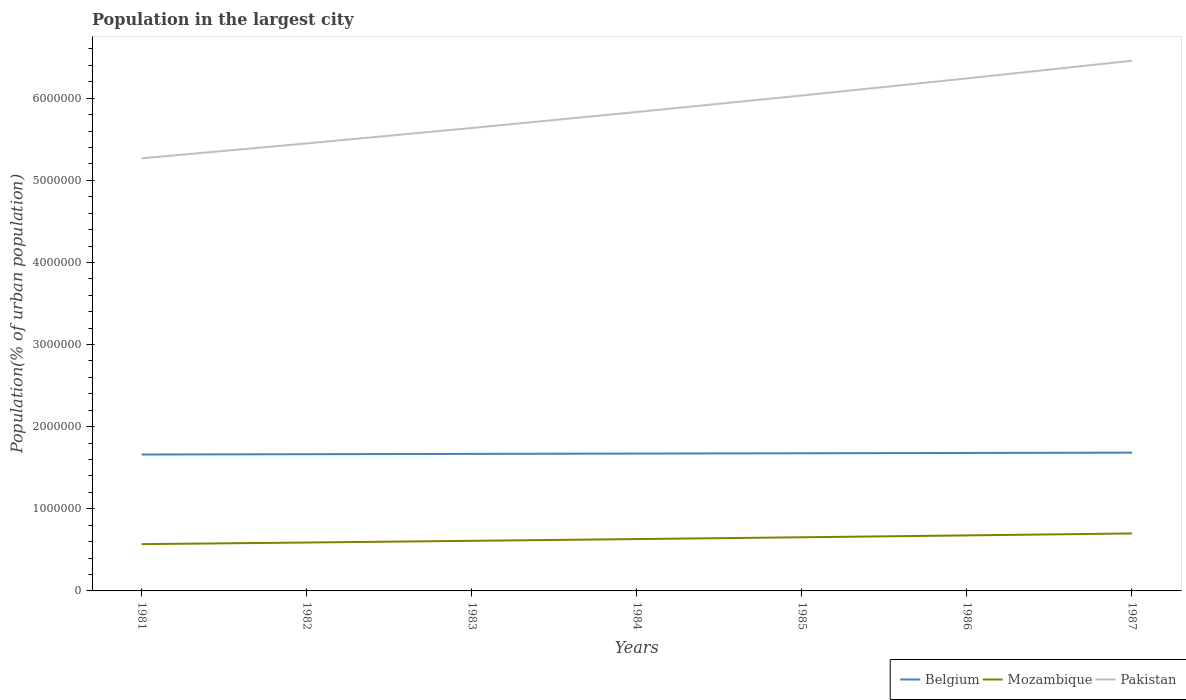Does the line corresponding to Mozambique intersect with the line corresponding to Belgium?
Ensure brevity in your answer.  No. Across all years, what is the maximum population in the largest city in Mozambique?
Your answer should be compact. 5.70e+05. In which year was the population in the largest city in Pakistan maximum?
Offer a terse response. 1981. What is the total population in the largest city in Belgium in the graph?
Offer a very short reply. -1.15e+04. What is the difference between the highest and the second highest population in the largest city in Mozambique?
Your answer should be very brief. 1.30e+05. Is the population in the largest city in Belgium strictly greater than the population in the largest city in Pakistan over the years?
Your answer should be very brief. Yes. How many years are there in the graph?
Make the answer very short. 7. Does the graph contain any zero values?
Your answer should be compact. No. Does the graph contain grids?
Your answer should be compact. No. How many legend labels are there?
Offer a very short reply. 3. What is the title of the graph?
Offer a very short reply. Population in the largest city. What is the label or title of the X-axis?
Provide a short and direct response. Years. What is the label or title of the Y-axis?
Make the answer very short. Population(% of urban population). What is the Population(% of urban population) of Belgium in 1981?
Make the answer very short. 1.66e+06. What is the Population(% of urban population) of Mozambique in 1981?
Your answer should be very brief. 5.70e+05. What is the Population(% of urban population) in Pakistan in 1981?
Ensure brevity in your answer.  5.27e+06. What is the Population(% of urban population) in Belgium in 1982?
Your response must be concise. 1.66e+06. What is the Population(% of urban population) of Mozambique in 1982?
Ensure brevity in your answer.  5.89e+05. What is the Population(% of urban population) in Pakistan in 1982?
Provide a succinct answer. 5.45e+06. What is the Population(% of urban population) of Belgium in 1983?
Your answer should be compact. 1.67e+06. What is the Population(% of urban population) in Mozambique in 1983?
Make the answer very short. 6.10e+05. What is the Population(% of urban population) in Pakistan in 1983?
Your answer should be compact. 5.64e+06. What is the Population(% of urban population) in Belgium in 1984?
Offer a terse response. 1.67e+06. What is the Population(% of urban population) of Mozambique in 1984?
Your answer should be very brief. 6.31e+05. What is the Population(% of urban population) of Pakistan in 1984?
Your answer should be compact. 5.83e+06. What is the Population(% of urban population) in Belgium in 1985?
Offer a terse response. 1.68e+06. What is the Population(% of urban population) of Mozambique in 1985?
Keep it short and to the point. 6.53e+05. What is the Population(% of urban population) in Pakistan in 1985?
Offer a very short reply. 6.03e+06. What is the Population(% of urban population) of Belgium in 1986?
Give a very brief answer. 1.68e+06. What is the Population(% of urban population) in Mozambique in 1986?
Your answer should be very brief. 6.76e+05. What is the Population(% of urban population) of Pakistan in 1986?
Provide a short and direct response. 6.24e+06. What is the Population(% of urban population) of Belgium in 1987?
Provide a short and direct response. 1.68e+06. What is the Population(% of urban population) of Mozambique in 1987?
Your answer should be very brief. 7.00e+05. What is the Population(% of urban population) in Pakistan in 1987?
Provide a short and direct response. 6.46e+06. Across all years, what is the maximum Population(% of urban population) of Belgium?
Keep it short and to the point. 1.68e+06. Across all years, what is the maximum Population(% of urban population) of Mozambique?
Keep it short and to the point. 7.00e+05. Across all years, what is the maximum Population(% of urban population) in Pakistan?
Offer a terse response. 6.46e+06. Across all years, what is the minimum Population(% of urban population) in Belgium?
Your answer should be compact. 1.66e+06. Across all years, what is the minimum Population(% of urban population) of Mozambique?
Make the answer very short. 5.70e+05. Across all years, what is the minimum Population(% of urban population) of Pakistan?
Make the answer very short. 5.27e+06. What is the total Population(% of urban population) in Belgium in the graph?
Your answer should be very brief. 1.17e+07. What is the total Population(% of urban population) in Mozambique in the graph?
Offer a very short reply. 4.43e+06. What is the total Population(% of urban population) of Pakistan in the graph?
Your response must be concise. 4.09e+07. What is the difference between the Population(% of urban population) of Belgium in 1981 and that in 1982?
Your response must be concise. -3804. What is the difference between the Population(% of urban population) in Mozambique in 1981 and that in 1982?
Offer a very short reply. -1.99e+04. What is the difference between the Population(% of urban population) in Pakistan in 1981 and that in 1982?
Your answer should be very brief. -1.82e+05. What is the difference between the Population(% of urban population) of Belgium in 1981 and that in 1983?
Offer a very short reply. -7617. What is the difference between the Population(% of urban population) of Mozambique in 1981 and that in 1983?
Your answer should be compact. -4.05e+04. What is the difference between the Population(% of urban population) of Pakistan in 1981 and that in 1983?
Offer a very short reply. -3.70e+05. What is the difference between the Population(% of urban population) of Belgium in 1981 and that in 1984?
Provide a short and direct response. -1.14e+04. What is the difference between the Population(% of urban population) in Mozambique in 1981 and that in 1984?
Your response must be concise. -6.18e+04. What is the difference between the Population(% of urban population) in Pakistan in 1981 and that in 1984?
Provide a succinct answer. -5.64e+05. What is the difference between the Population(% of urban population) in Belgium in 1981 and that in 1985?
Keep it short and to the point. -1.53e+04. What is the difference between the Population(% of urban population) of Mozambique in 1981 and that in 1985?
Your answer should be very brief. -8.38e+04. What is the difference between the Population(% of urban population) in Pakistan in 1981 and that in 1985?
Offer a very short reply. -7.65e+05. What is the difference between the Population(% of urban population) in Belgium in 1981 and that in 1986?
Give a very brief answer. -1.91e+04. What is the difference between the Population(% of urban population) of Mozambique in 1981 and that in 1986?
Make the answer very short. -1.07e+05. What is the difference between the Population(% of urban population) of Pakistan in 1981 and that in 1986?
Your answer should be compact. -9.73e+05. What is the difference between the Population(% of urban population) of Belgium in 1981 and that in 1987?
Provide a short and direct response. -2.30e+04. What is the difference between the Population(% of urban population) of Mozambique in 1981 and that in 1987?
Your response must be concise. -1.30e+05. What is the difference between the Population(% of urban population) in Pakistan in 1981 and that in 1987?
Offer a terse response. -1.19e+06. What is the difference between the Population(% of urban population) of Belgium in 1982 and that in 1983?
Your answer should be very brief. -3813. What is the difference between the Population(% of urban population) of Mozambique in 1982 and that in 1983?
Your answer should be compact. -2.06e+04. What is the difference between the Population(% of urban population) in Pakistan in 1982 and that in 1983?
Offer a very short reply. -1.88e+05. What is the difference between the Population(% of urban population) of Belgium in 1982 and that in 1984?
Give a very brief answer. -7639. What is the difference between the Population(% of urban population) of Mozambique in 1982 and that in 1984?
Provide a short and direct response. -4.19e+04. What is the difference between the Population(% of urban population) of Pakistan in 1982 and that in 1984?
Offer a terse response. -3.83e+05. What is the difference between the Population(% of urban population) of Belgium in 1982 and that in 1985?
Your answer should be very brief. -1.15e+04. What is the difference between the Population(% of urban population) of Mozambique in 1982 and that in 1985?
Offer a very short reply. -6.39e+04. What is the difference between the Population(% of urban population) of Pakistan in 1982 and that in 1985?
Your response must be concise. -5.83e+05. What is the difference between the Population(% of urban population) in Belgium in 1982 and that in 1986?
Make the answer very short. -1.53e+04. What is the difference between the Population(% of urban population) of Mozambique in 1982 and that in 1986?
Keep it short and to the point. -8.68e+04. What is the difference between the Population(% of urban population) in Pakistan in 1982 and that in 1986?
Ensure brevity in your answer.  -7.91e+05. What is the difference between the Population(% of urban population) of Belgium in 1982 and that in 1987?
Your response must be concise. -1.92e+04. What is the difference between the Population(% of urban population) of Mozambique in 1982 and that in 1987?
Provide a succinct answer. -1.10e+05. What is the difference between the Population(% of urban population) in Pakistan in 1982 and that in 1987?
Give a very brief answer. -1.01e+06. What is the difference between the Population(% of urban population) in Belgium in 1983 and that in 1984?
Your answer should be compact. -3826. What is the difference between the Population(% of urban population) of Mozambique in 1983 and that in 1984?
Provide a short and direct response. -2.13e+04. What is the difference between the Population(% of urban population) in Pakistan in 1983 and that in 1984?
Keep it short and to the point. -1.95e+05. What is the difference between the Population(% of urban population) in Belgium in 1983 and that in 1985?
Provide a short and direct response. -7652. What is the difference between the Population(% of urban population) of Mozambique in 1983 and that in 1985?
Your response must be concise. -4.34e+04. What is the difference between the Population(% of urban population) of Pakistan in 1983 and that in 1985?
Your answer should be very brief. -3.96e+05. What is the difference between the Population(% of urban population) in Belgium in 1983 and that in 1986?
Give a very brief answer. -1.15e+04. What is the difference between the Population(% of urban population) in Mozambique in 1983 and that in 1986?
Ensure brevity in your answer.  -6.62e+04. What is the difference between the Population(% of urban population) in Pakistan in 1983 and that in 1986?
Make the answer very short. -6.04e+05. What is the difference between the Population(% of urban population) of Belgium in 1983 and that in 1987?
Provide a succinct answer. -1.53e+04. What is the difference between the Population(% of urban population) of Mozambique in 1983 and that in 1987?
Offer a very short reply. -8.98e+04. What is the difference between the Population(% of urban population) of Pakistan in 1983 and that in 1987?
Give a very brief answer. -8.19e+05. What is the difference between the Population(% of urban population) in Belgium in 1984 and that in 1985?
Your answer should be very brief. -3826. What is the difference between the Population(% of urban population) in Mozambique in 1984 and that in 1985?
Offer a terse response. -2.20e+04. What is the difference between the Population(% of urban population) in Pakistan in 1984 and that in 1985?
Your response must be concise. -2.01e+05. What is the difference between the Population(% of urban population) in Belgium in 1984 and that in 1986?
Offer a terse response. -7665. What is the difference between the Population(% of urban population) of Mozambique in 1984 and that in 1986?
Give a very brief answer. -4.48e+04. What is the difference between the Population(% of urban population) in Pakistan in 1984 and that in 1986?
Offer a very short reply. -4.09e+05. What is the difference between the Population(% of urban population) in Belgium in 1984 and that in 1987?
Provide a succinct answer. -1.15e+04. What is the difference between the Population(% of urban population) of Mozambique in 1984 and that in 1987?
Provide a succinct answer. -6.85e+04. What is the difference between the Population(% of urban population) of Pakistan in 1984 and that in 1987?
Your answer should be very brief. -6.24e+05. What is the difference between the Population(% of urban population) in Belgium in 1985 and that in 1986?
Your answer should be very brief. -3839. What is the difference between the Population(% of urban population) of Mozambique in 1985 and that in 1986?
Your answer should be very brief. -2.28e+04. What is the difference between the Population(% of urban population) in Pakistan in 1985 and that in 1986?
Make the answer very short. -2.08e+05. What is the difference between the Population(% of urban population) in Belgium in 1985 and that in 1987?
Make the answer very short. -7687. What is the difference between the Population(% of urban population) in Mozambique in 1985 and that in 1987?
Provide a succinct answer. -4.64e+04. What is the difference between the Population(% of urban population) in Pakistan in 1985 and that in 1987?
Your answer should be compact. -4.23e+05. What is the difference between the Population(% of urban population) of Belgium in 1986 and that in 1987?
Your answer should be very brief. -3848. What is the difference between the Population(% of urban population) of Mozambique in 1986 and that in 1987?
Make the answer very short. -2.36e+04. What is the difference between the Population(% of urban population) of Pakistan in 1986 and that in 1987?
Provide a succinct answer. -2.15e+05. What is the difference between the Population(% of urban population) in Belgium in 1981 and the Population(% of urban population) in Mozambique in 1982?
Your response must be concise. 1.07e+06. What is the difference between the Population(% of urban population) of Belgium in 1981 and the Population(% of urban population) of Pakistan in 1982?
Give a very brief answer. -3.79e+06. What is the difference between the Population(% of urban population) of Mozambique in 1981 and the Population(% of urban population) of Pakistan in 1982?
Your answer should be very brief. -4.88e+06. What is the difference between the Population(% of urban population) of Belgium in 1981 and the Population(% of urban population) of Mozambique in 1983?
Offer a very short reply. 1.05e+06. What is the difference between the Population(% of urban population) of Belgium in 1981 and the Population(% of urban population) of Pakistan in 1983?
Give a very brief answer. -3.98e+06. What is the difference between the Population(% of urban population) of Mozambique in 1981 and the Population(% of urban population) of Pakistan in 1983?
Offer a very short reply. -5.07e+06. What is the difference between the Population(% of urban population) in Belgium in 1981 and the Population(% of urban population) in Mozambique in 1984?
Provide a short and direct response. 1.03e+06. What is the difference between the Population(% of urban population) of Belgium in 1981 and the Population(% of urban population) of Pakistan in 1984?
Ensure brevity in your answer.  -4.17e+06. What is the difference between the Population(% of urban population) in Mozambique in 1981 and the Population(% of urban population) in Pakistan in 1984?
Provide a succinct answer. -5.26e+06. What is the difference between the Population(% of urban population) in Belgium in 1981 and the Population(% of urban population) in Mozambique in 1985?
Your response must be concise. 1.01e+06. What is the difference between the Population(% of urban population) of Belgium in 1981 and the Population(% of urban population) of Pakistan in 1985?
Your response must be concise. -4.37e+06. What is the difference between the Population(% of urban population) in Mozambique in 1981 and the Population(% of urban population) in Pakistan in 1985?
Keep it short and to the point. -5.46e+06. What is the difference between the Population(% of urban population) of Belgium in 1981 and the Population(% of urban population) of Mozambique in 1986?
Offer a terse response. 9.85e+05. What is the difference between the Population(% of urban population) in Belgium in 1981 and the Population(% of urban population) in Pakistan in 1986?
Offer a very short reply. -4.58e+06. What is the difference between the Population(% of urban population) of Mozambique in 1981 and the Population(% of urban population) of Pakistan in 1986?
Give a very brief answer. -5.67e+06. What is the difference between the Population(% of urban population) in Belgium in 1981 and the Population(% of urban population) in Mozambique in 1987?
Give a very brief answer. 9.61e+05. What is the difference between the Population(% of urban population) of Belgium in 1981 and the Population(% of urban population) of Pakistan in 1987?
Provide a succinct answer. -4.79e+06. What is the difference between the Population(% of urban population) in Mozambique in 1981 and the Population(% of urban population) in Pakistan in 1987?
Keep it short and to the point. -5.89e+06. What is the difference between the Population(% of urban population) of Belgium in 1982 and the Population(% of urban population) of Mozambique in 1983?
Your answer should be compact. 1.05e+06. What is the difference between the Population(% of urban population) of Belgium in 1982 and the Population(% of urban population) of Pakistan in 1983?
Offer a very short reply. -3.97e+06. What is the difference between the Population(% of urban population) of Mozambique in 1982 and the Population(% of urban population) of Pakistan in 1983?
Your answer should be compact. -5.05e+06. What is the difference between the Population(% of urban population) of Belgium in 1982 and the Population(% of urban population) of Mozambique in 1984?
Ensure brevity in your answer.  1.03e+06. What is the difference between the Population(% of urban population) in Belgium in 1982 and the Population(% of urban population) in Pakistan in 1984?
Keep it short and to the point. -4.17e+06. What is the difference between the Population(% of urban population) in Mozambique in 1982 and the Population(% of urban population) in Pakistan in 1984?
Your answer should be compact. -5.24e+06. What is the difference between the Population(% of urban population) in Belgium in 1982 and the Population(% of urban population) in Mozambique in 1985?
Your response must be concise. 1.01e+06. What is the difference between the Population(% of urban population) in Belgium in 1982 and the Population(% of urban population) in Pakistan in 1985?
Your response must be concise. -4.37e+06. What is the difference between the Population(% of urban population) of Mozambique in 1982 and the Population(% of urban population) of Pakistan in 1985?
Give a very brief answer. -5.44e+06. What is the difference between the Population(% of urban population) in Belgium in 1982 and the Population(% of urban population) in Mozambique in 1986?
Provide a short and direct response. 9.88e+05. What is the difference between the Population(% of urban population) of Belgium in 1982 and the Population(% of urban population) of Pakistan in 1986?
Give a very brief answer. -4.58e+06. What is the difference between the Population(% of urban population) of Mozambique in 1982 and the Population(% of urban population) of Pakistan in 1986?
Your answer should be very brief. -5.65e+06. What is the difference between the Population(% of urban population) in Belgium in 1982 and the Population(% of urban population) in Mozambique in 1987?
Ensure brevity in your answer.  9.65e+05. What is the difference between the Population(% of urban population) of Belgium in 1982 and the Population(% of urban population) of Pakistan in 1987?
Make the answer very short. -4.79e+06. What is the difference between the Population(% of urban population) of Mozambique in 1982 and the Population(% of urban population) of Pakistan in 1987?
Ensure brevity in your answer.  -5.87e+06. What is the difference between the Population(% of urban population) in Belgium in 1983 and the Population(% of urban population) in Mozambique in 1984?
Your answer should be very brief. 1.04e+06. What is the difference between the Population(% of urban population) in Belgium in 1983 and the Population(% of urban population) in Pakistan in 1984?
Your answer should be very brief. -4.16e+06. What is the difference between the Population(% of urban population) of Mozambique in 1983 and the Population(% of urban population) of Pakistan in 1984?
Give a very brief answer. -5.22e+06. What is the difference between the Population(% of urban population) in Belgium in 1983 and the Population(% of urban population) in Mozambique in 1985?
Keep it short and to the point. 1.02e+06. What is the difference between the Population(% of urban population) of Belgium in 1983 and the Population(% of urban population) of Pakistan in 1985?
Provide a succinct answer. -4.36e+06. What is the difference between the Population(% of urban population) of Mozambique in 1983 and the Population(% of urban population) of Pakistan in 1985?
Keep it short and to the point. -5.42e+06. What is the difference between the Population(% of urban population) in Belgium in 1983 and the Population(% of urban population) in Mozambique in 1986?
Provide a short and direct response. 9.92e+05. What is the difference between the Population(% of urban population) of Belgium in 1983 and the Population(% of urban population) of Pakistan in 1986?
Your response must be concise. -4.57e+06. What is the difference between the Population(% of urban population) in Mozambique in 1983 and the Population(% of urban population) in Pakistan in 1986?
Offer a very short reply. -5.63e+06. What is the difference between the Population(% of urban population) of Belgium in 1983 and the Population(% of urban population) of Mozambique in 1987?
Ensure brevity in your answer.  9.69e+05. What is the difference between the Population(% of urban population) of Belgium in 1983 and the Population(% of urban population) of Pakistan in 1987?
Provide a succinct answer. -4.79e+06. What is the difference between the Population(% of urban population) in Mozambique in 1983 and the Population(% of urban population) in Pakistan in 1987?
Give a very brief answer. -5.85e+06. What is the difference between the Population(% of urban population) of Belgium in 1984 and the Population(% of urban population) of Mozambique in 1985?
Keep it short and to the point. 1.02e+06. What is the difference between the Population(% of urban population) in Belgium in 1984 and the Population(% of urban population) in Pakistan in 1985?
Give a very brief answer. -4.36e+06. What is the difference between the Population(% of urban population) of Mozambique in 1984 and the Population(% of urban population) of Pakistan in 1985?
Offer a terse response. -5.40e+06. What is the difference between the Population(% of urban population) in Belgium in 1984 and the Population(% of urban population) in Mozambique in 1986?
Provide a succinct answer. 9.96e+05. What is the difference between the Population(% of urban population) in Belgium in 1984 and the Population(% of urban population) in Pakistan in 1986?
Keep it short and to the point. -4.57e+06. What is the difference between the Population(% of urban population) of Mozambique in 1984 and the Population(% of urban population) of Pakistan in 1986?
Give a very brief answer. -5.61e+06. What is the difference between the Population(% of urban population) in Belgium in 1984 and the Population(% of urban population) in Mozambique in 1987?
Your response must be concise. 9.73e+05. What is the difference between the Population(% of urban population) of Belgium in 1984 and the Population(% of urban population) of Pakistan in 1987?
Keep it short and to the point. -4.78e+06. What is the difference between the Population(% of urban population) of Mozambique in 1984 and the Population(% of urban population) of Pakistan in 1987?
Give a very brief answer. -5.82e+06. What is the difference between the Population(% of urban population) in Belgium in 1985 and the Population(% of urban population) in Mozambique in 1986?
Ensure brevity in your answer.  1.00e+06. What is the difference between the Population(% of urban population) of Belgium in 1985 and the Population(% of urban population) of Pakistan in 1986?
Provide a succinct answer. -4.56e+06. What is the difference between the Population(% of urban population) of Mozambique in 1985 and the Population(% of urban population) of Pakistan in 1986?
Your answer should be very brief. -5.59e+06. What is the difference between the Population(% of urban population) of Belgium in 1985 and the Population(% of urban population) of Mozambique in 1987?
Provide a succinct answer. 9.76e+05. What is the difference between the Population(% of urban population) in Belgium in 1985 and the Population(% of urban population) in Pakistan in 1987?
Provide a short and direct response. -4.78e+06. What is the difference between the Population(% of urban population) of Mozambique in 1985 and the Population(% of urban population) of Pakistan in 1987?
Your answer should be compact. -5.80e+06. What is the difference between the Population(% of urban population) in Belgium in 1986 and the Population(% of urban population) in Mozambique in 1987?
Provide a short and direct response. 9.80e+05. What is the difference between the Population(% of urban population) of Belgium in 1986 and the Population(% of urban population) of Pakistan in 1987?
Provide a short and direct response. -4.78e+06. What is the difference between the Population(% of urban population) in Mozambique in 1986 and the Population(% of urban population) in Pakistan in 1987?
Give a very brief answer. -5.78e+06. What is the average Population(% of urban population) of Belgium per year?
Offer a terse response. 1.67e+06. What is the average Population(% of urban population) in Mozambique per year?
Your response must be concise. 6.33e+05. What is the average Population(% of urban population) of Pakistan per year?
Provide a short and direct response. 5.84e+06. In the year 1981, what is the difference between the Population(% of urban population) in Belgium and Population(% of urban population) in Mozambique?
Ensure brevity in your answer.  1.09e+06. In the year 1981, what is the difference between the Population(% of urban population) in Belgium and Population(% of urban population) in Pakistan?
Provide a short and direct response. -3.61e+06. In the year 1981, what is the difference between the Population(% of urban population) in Mozambique and Population(% of urban population) in Pakistan?
Ensure brevity in your answer.  -4.70e+06. In the year 1982, what is the difference between the Population(% of urban population) of Belgium and Population(% of urban population) of Mozambique?
Your response must be concise. 1.08e+06. In the year 1982, what is the difference between the Population(% of urban population) of Belgium and Population(% of urban population) of Pakistan?
Your answer should be very brief. -3.78e+06. In the year 1982, what is the difference between the Population(% of urban population) in Mozambique and Population(% of urban population) in Pakistan?
Your answer should be very brief. -4.86e+06. In the year 1983, what is the difference between the Population(% of urban population) in Belgium and Population(% of urban population) in Mozambique?
Provide a short and direct response. 1.06e+06. In the year 1983, what is the difference between the Population(% of urban population) of Belgium and Population(% of urban population) of Pakistan?
Offer a terse response. -3.97e+06. In the year 1983, what is the difference between the Population(% of urban population) of Mozambique and Population(% of urban population) of Pakistan?
Give a very brief answer. -5.03e+06. In the year 1984, what is the difference between the Population(% of urban population) in Belgium and Population(% of urban population) in Mozambique?
Keep it short and to the point. 1.04e+06. In the year 1984, what is the difference between the Population(% of urban population) in Belgium and Population(% of urban population) in Pakistan?
Your answer should be compact. -4.16e+06. In the year 1984, what is the difference between the Population(% of urban population) of Mozambique and Population(% of urban population) of Pakistan?
Your response must be concise. -5.20e+06. In the year 1985, what is the difference between the Population(% of urban population) of Belgium and Population(% of urban population) of Mozambique?
Provide a succinct answer. 1.02e+06. In the year 1985, what is the difference between the Population(% of urban population) of Belgium and Population(% of urban population) of Pakistan?
Make the answer very short. -4.36e+06. In the year 1985, what is the difference between the Population(% of urban population) of Mozambique and Population(% of urban population) of Pakistan?
Your response must be concise. -5.38e+06. In the year 1986, what is the difference between the Population(% of urban population) in Belgium and Population(% of urban population) in Mozambique?
Your answer should be very brief. 1.00e+06. In the year 1986, what is the difference between the Population(% of urban population) of Belgium and Population(% of urban population) of Pakistan?
Offer a very short reply. -4.56e+06. In the year 1986, what is the difference between the Population(% of urban population) in Mozambique and Population(% of urban population) in Pakistan?
Ensure brevity in your answer.  -5.56e+06. In the year 1987, what is the difference between the Population(% of urban population) of Belgium and Population(% of urban population) of Mozambique?
Make the answer very short. 9.84e+05. In the year 1987, what is the difference between the Population(% of urban population) of Belgium and Population(% of urban population) of Pakistan?
Ensure brevity in your answer.  -4.77e+06. In the year 1987, what is the difference between the Population(% of urban population) of Mozambique and Population(% of urban population) of Pakistan?
Provide a short and direct response. -5.76e+06. What is the ratio of the Population(% of urban population) of Mozambique in 1981 to that in 1982?
Ensure brevity in your answer.  0.97. What is the ratio of the Population(% of urban population) of Pakistan in 1981 to that in 1982?
Your answer should be very brief. 0.97. What is the ratio of the Population(% of urban population) in Mozambique in 1981 to that in 1983?
Ensure brevity in your answer.  0.93. What is the ratio of the Population(% of urban population) in Pakistan in 1981 to that in 1983?
Offer a very short reply. 0.93. What is the ratio of the Population(% of urban population) of Belgium in 1981 to that in 1984?
Your answer should be compact. 0.99. What is the ratio of the Population(% of urban population) of Mozambique in 1981 to that in 1984?
Ensure brevity in your answer.  0.9. What is the ratio of the Population(% of urban population) in Pakistan in 1981 to that in 1984?
Your answer should be compact. 0.9. What is the ratio of the Population(% of urban population) of Belgium in 1981 to that in 1985?
Offer a terse response. 0.99. What is the ratio of the Population(% of urban population) in Mozambique in 1981 to that in 1985?
Ensure brevity in your answer.  0.87. What is the ratio of the Population(% of urban population) in Pakistan in 1981 to that in 1985?
Offer a very short reply. 0.87. What is the ratio of the Population(% of urban population) in Mozambique in 1981 to that in 1986?
Offer a terse response. 0.84. What is the ratio of the Population(% of urban population) in Pakistan in 1981 to that in 1986?
Your answer should be compact. 0.84. What is the ratio of the Population(% of urban population) in Belgium in 1981 to that in 1987?
Offer a very short reply. 0.99. What is the ratio of the Population(% of urban population) of Mozambique in 1981 to that in 1987?
Your response must be concise. 0.81. What is the ratio of the Population(% of urban population) of Pakistan in 1981 to that in 1987?
Make the answer very short. 0.82. What is the ratio of the Population(% of urban population) in Mozambique in 1982 to that in 1983?
Ensure brevity in your answer.  0.97. What is the ratio of the Population(% of urban population) of Pakistan in 1982 to that in 1983?
Provide a succinct answer. 0.97. What is the ratio of the Population(% of urban population) in Belgium in 1982 to that in 1984?
Provide a succinct answer. 1. What is the ratio of the Population(% of urban population) in Mozambique in 1982 to that in 1984?
Keep it short and to the point. 0.93. What is the ratio of the Population(% of urban population) of Pakistan in 1982 to that in 1984?
Provide a short and direct response. 0.93. What is the ratio of the Population(% of urban population) in Belgium in 1982 to that in 1985?
Ensure brevity in your answer.  0.99. What is the ratio of the Population(% of urban population) in Mozambique in 1982 to that in 1985?
Your answer should be very brief. 0.9. What is the ratio of the Population(% of urban population) in Pakistan in 1982 to that in 1985?
Your answer should be compact. 0.9. What is the ratio of the Population(% of urban population) in Belgium in 1982 to that in 1986?
Make the answer very short. 0.99. What is the ratio of the Population(% of urban population) in Mozambique in 1982 to that in 1986?
Your answer should be very brief. 0.87. What is the ratio of the Population(% of urban population) in Pakistan in 1982 to that in 1986?
Make the answer very short. 0.87. What is the ratio of the Population(% of urban population) of Belgium in 1982 to that in 1987?
Keep it short and to the point. 0.99. What is the ratio of the Population(% of urban population) of Mozambique in 1982 to that in 1987?
Provide a short and direct response. 0.84. What is the ratio of the Population(% of urban population) in Pakistan in 1982 to that in 1987?
Your response must be concise. 0.84. What is the ratio of the Population(% of urban population) of Belgium in 1983 to that in 1984?
Offer a terse response. 1. What is the ratio of the Population(% of urban population) of Mozambique in 1983 to that in 1984?
Offer a very short reply. 0.97. What is the ratio of the Population(% of urban population) of Pakistan in 1983 to that in 1984?
Keep it short and to the point. 0.97. What is the ratio of the Population(% of urban population) of Mozambique in 1983 to that in 1985?
Keep it short and to the point. 0.93. What is the ratio of the Population(% of urban population) of Pakistan in 1983 to that in 1985?
Make the answer very short. 0.93. What is the ratio of the Population(% of urban population) of Mozambique in 1983 to that in 1986?
Provide a succinct answer. 0.9. What is the ratio of the Population(% of urban population) in Pakistan in 1983 to that in 1986?
Offer a very short reply. 0.9. What is the ratio of the Population(% of urban population) in Belgium in 1983 to that in 1987?
Your answer should be compact. 0.99. What is the ratio of the Population(% of urban population) in Mozambique in 1983 to that in 1987?
Provide a succinct answer. 0.87. What is the ratio of the Population(% of urban population) in Pakistan in 1983 to that in 1987?
Make the answer very short. 0.87. What is the ratio of the Population(% of urban population) of Mozambique in 1984 to that in 1985?
Your response must be concise. 0.97. What is the ratio of the Population(% of urban population) in Pakistan in 1984 to that in 1985?
Offer a very short reply. 0.97. What is the ratio of the Population(% of urban population) in Mozambique in 1984 to that in 1986?
Offer a terse response. 0.93. What is the ratio of the Population(% of urban population) of Pakistan in 1984 to that in 1986?
Your answer should be compact. 0.93. What is the ratio of the Population(% of urban population) of Belgium in 1984 to that in 1987?
Keep it short and to the point. 0.99. What is the ratio of the Population(% of urban population) in Mozambique in 1984 to that in 1987?
Ensure brevity in your answer.  0.9. What is the ratio of the Population(% of urban population) of Pakistan in 1984 to that in 1987?
Your answer should be very brief. 0.9. What is the ratio of the Population(% of urban population) of Mozambique in 1985 to that in 1986?
Give a very brief answer. 0.97. What is the ratio of the Population(% of urban population) of Pakistan in 1985 to that in 1986?
Keep it short and to the point. 0.97. What is the ratio of the Population(% of urban population) in Belgium in 1985 to that in 1987?
Give a very brief answer. 1. What is the ratio of the Population(% of urban population) of Mozambique in 1985 to that in 1987?
Your response must be concise. 0.93. What is the ratio of the Population(% of urban population) of Pakistan in 1985 to that in 1987?
Provide a succinct answer. 0.93. What is the ratio of the Population(% of urban population) in Belgium in 1986 to that in 1987?
Give a very brief answer. 1. What is the ratio of the Population(% of urban population) of Mozambique in 1986 to that in 1987?
Ensure brevity in your answer.  0.97. What is the ratio of the Population(% of urban population) of Pakistan in 1986 to that in 1987?
Your answer should be very brief. 0.97. What is the difference between the highest and the second highest Population(% of urban population) of Belgium?
Provide a succinct answer. 3848. What is the difference between the highest and the second highest Population(% of urban population) of Mozambique?
Offer a very short reply. 2.36e+04. What is the difference between the highest and the second highest Population(% of urban population) in Pakistan?
Make the answer very short. 2.15e+05. What is the difference between the highest and the lowest Population(% of urban population) of Belgium?
Ensure brevity in your answer.  2.30e+04. What is the difference between the highest and the lowest Population(% of urban population) in Mozambique?
Keep it short and to the point. 1.30e+05. What is the difference between the highest and the lowest Population(% of urban population) in Pakistan?
Your answer should be very brief. 1.19e+06. 